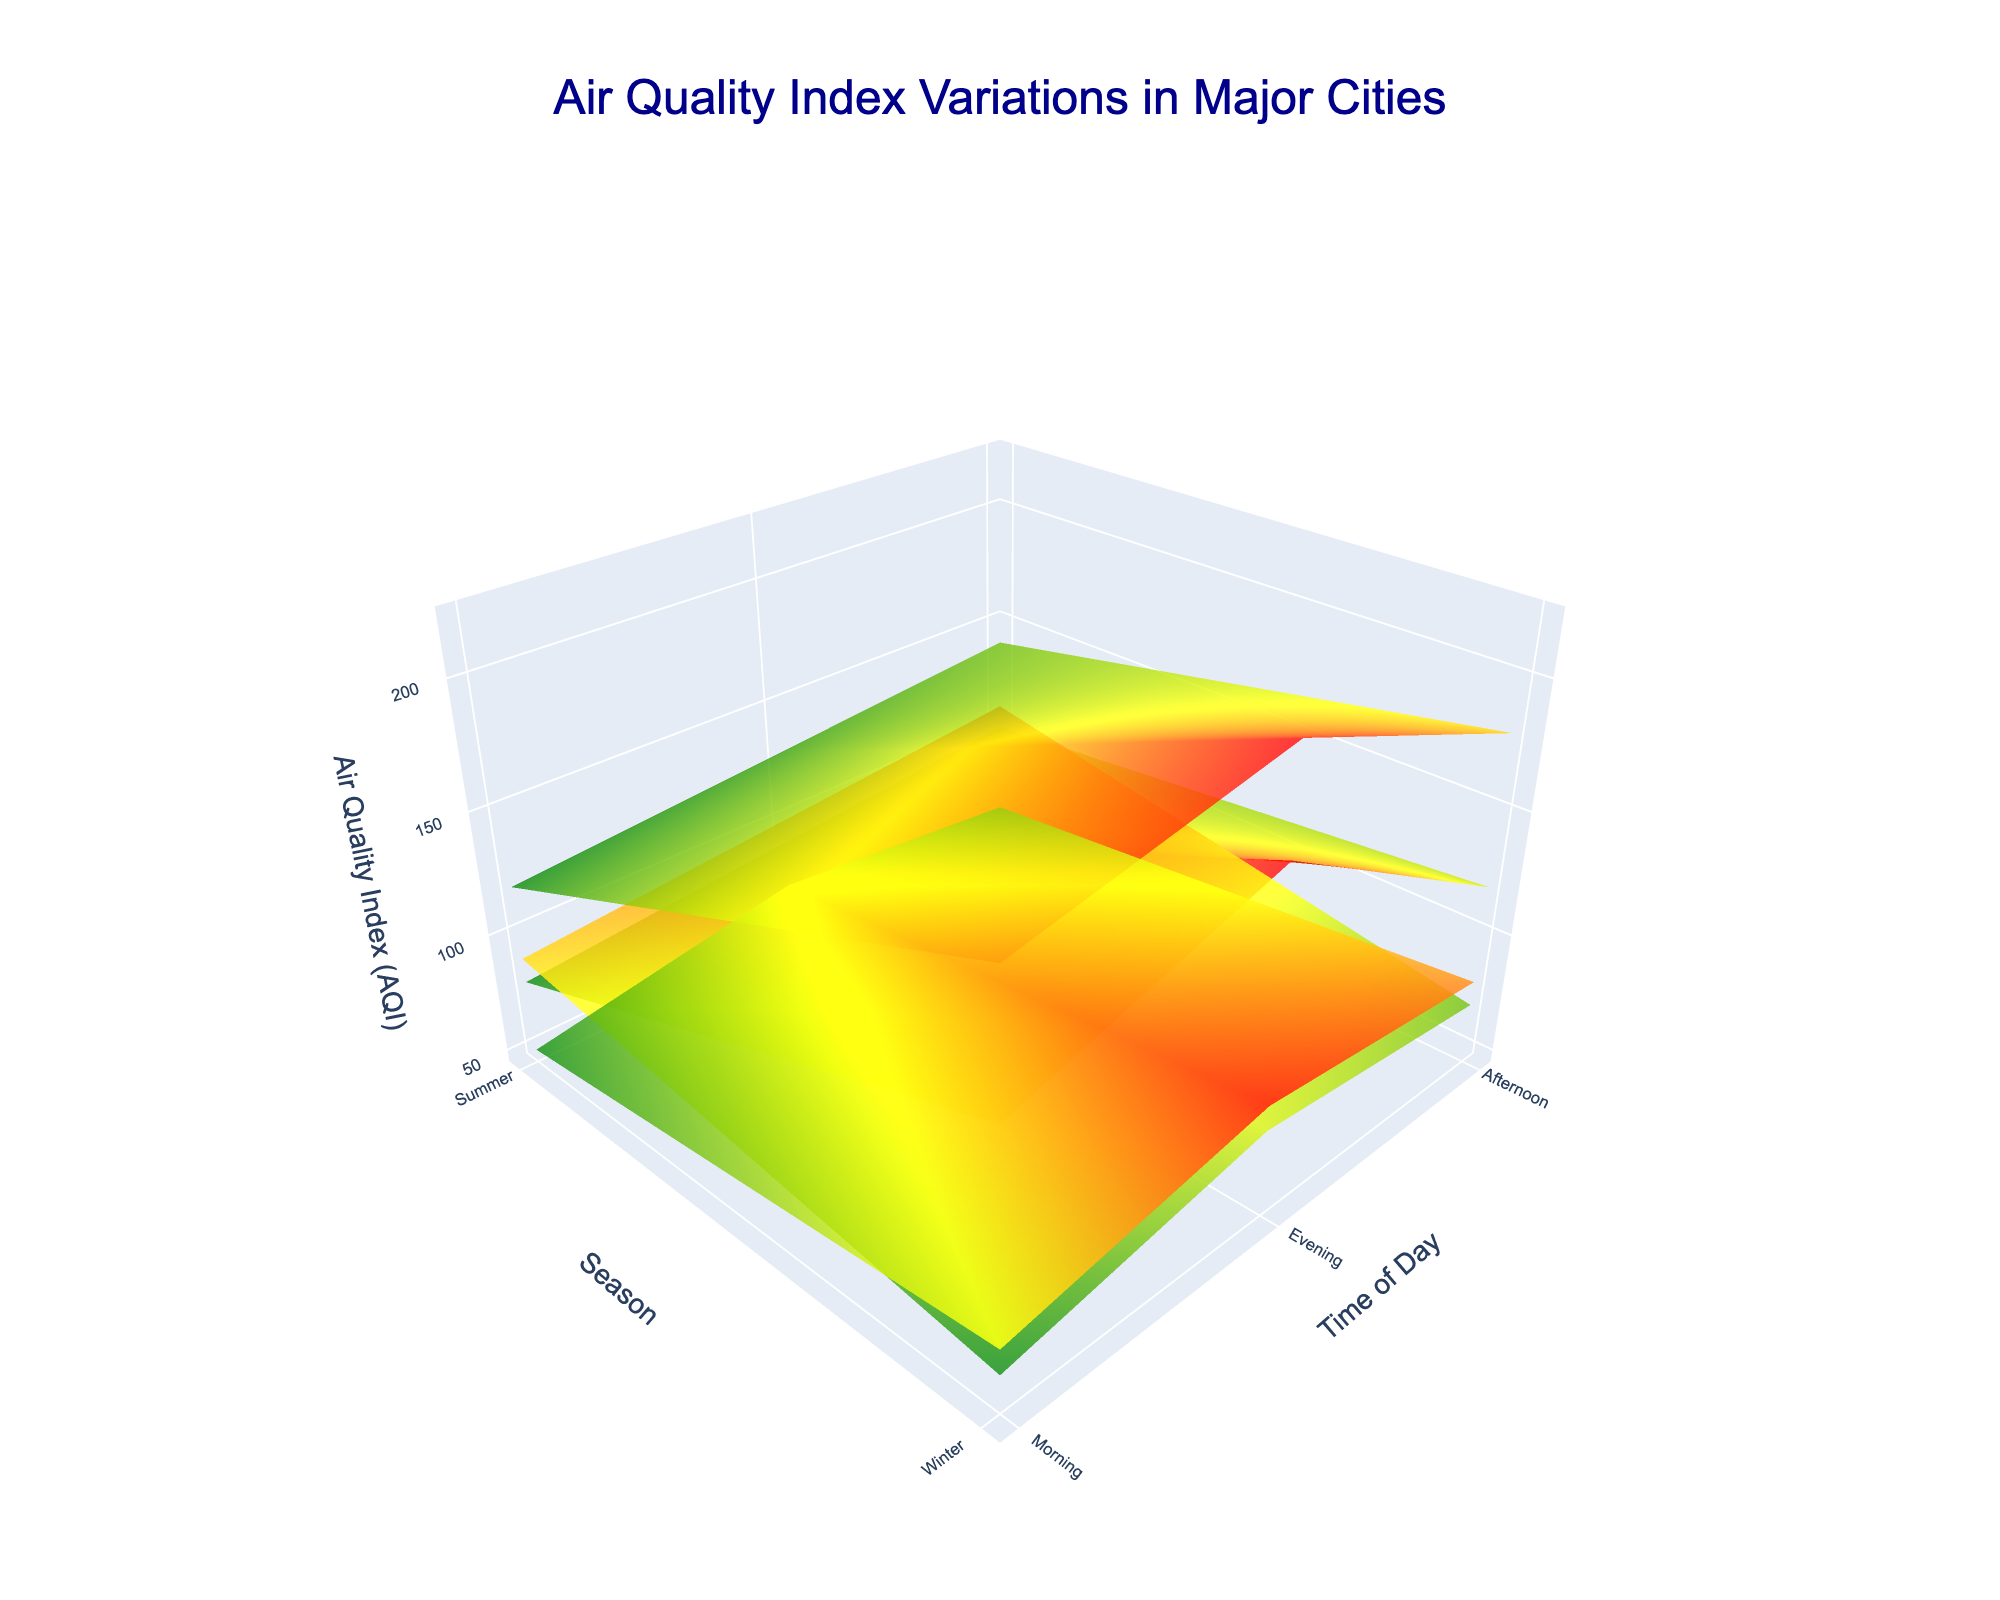what is the title of the plot? The title is usually displayed at the top center of the plot. In this case, the title is "Air Quality Index Variations in Major Cities".
Answer: Air Quality Index Variations in Major Cities how many cities are included in the plot? The plot represents the variations in AQI for different cities. By examining the legend and surfaces in the plot, it is clear that there are four cities: Beijing, New Delhi, Los Angeles, and Tokyo.
Answer: Four cities during which time of day did New Delhi have the highest AQI in winter? Looking at the surface for New Delhi during winter, the highest AQI value can be observed in the evening time of day.
Answer: Evening which season has the better air quality in Beijing? By comparing the two surfaces representing Beijing for summer and winter, it can be seen that the AQI values in summer are generally lower than those in winter, indicating better air quality.
Answer: Summer what is the general trend of AQI in Los Angeles from morning to evening in summer? Observing the Los Angeles surface for summer, the AQI values increase from morning to afternoon and then slightly decrease in the evening, suggesting a peak in the afternoon.
Answer: Increases then decreases compare the air quality between Tokyo and Los Angeles in summer mornings. which city has a better AQI? By examining the surfaces of Tokyo and Los Angeles for summer mornings, the AQI for Tokyo in summer mornings is 50, while that for Los Angeles is 90. Thus, Tokyo has a better AQI in summer mornings.
Answer: Tokyo which city shows the most significant change in AQI from winter to summer during mornings? Compare the morning AQI values for each city across the two seasons. For Beijing, it drops from 150 to 80; for New Delhi, it drops from 200 to 120; for Los Angeles, it rises from 60 to 90; and for Tokyo, it drops from 70 to 50. The most significant change is seen in New Delhi (200 to 120).
Answer: New Delhi what is the overall trend for air quality in major cities during summer afternoons? Analyze the AQI surfaces of all cities during summer afternoons. Beijing shows an increase to 100, Los Angeles reaches 110, Tokyo shows a rise to 60, and New Delhi goes to 140. Summer afternoons generally see higher AQI values than summer mornings except for Tokyo, which has a moderate rise.
Answer: AQI generally increases 